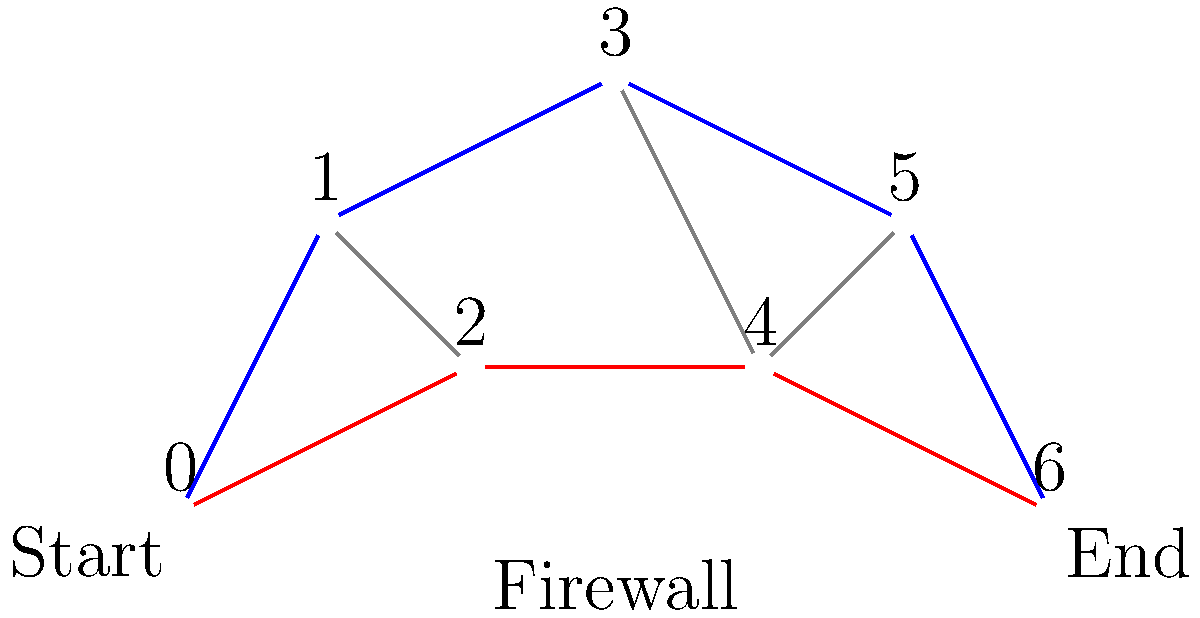In this firewall configuration maze, which path represents the shortest and most secure route from the start node (0) to the end node (6)? Consider that each edge represents a different security protocol, and the goal is to minimize the number of protocol changes while maintaining a high level of security. To determine the shortest and most secure path through the firewall configuration maze, we need to analyze the available routes and consider the number of edges (protocol changes) in each path:

1. Blue path: 0 → 1 → 3 → 5 → 6 (4 edges)
2. Red path: 0 → 2 → 4 → 6 (3 edges)

Step 1: Count the number of edges in each path.
The blue path has 4 edges, while the red path has 3 edges.

Step 2: Consider security implications.
Both paths go through the entire firewall configuration, so they can be considered equally secure in terms of coverage.

Step 3: Analyze protocol changes.
The red path has fewer edges, which means fewer protocol changes. This is generally preferable in cybersecurity as it reduces complexity and potential vulnerabilities at transition points.

Step 4: Evaluate the trade-off between path length and security.
In this case, the red path is both shorter (fewer edges) and potentially more secure (fewer protocol transitions) without sacrificing coverage of the firewall configuration.

Therefore, the red path (0 → 2 → 4 → 6) represents the shortest and most secure route through the firewall configuration maze.
Answer: 0 → 2 → 4 → 6 